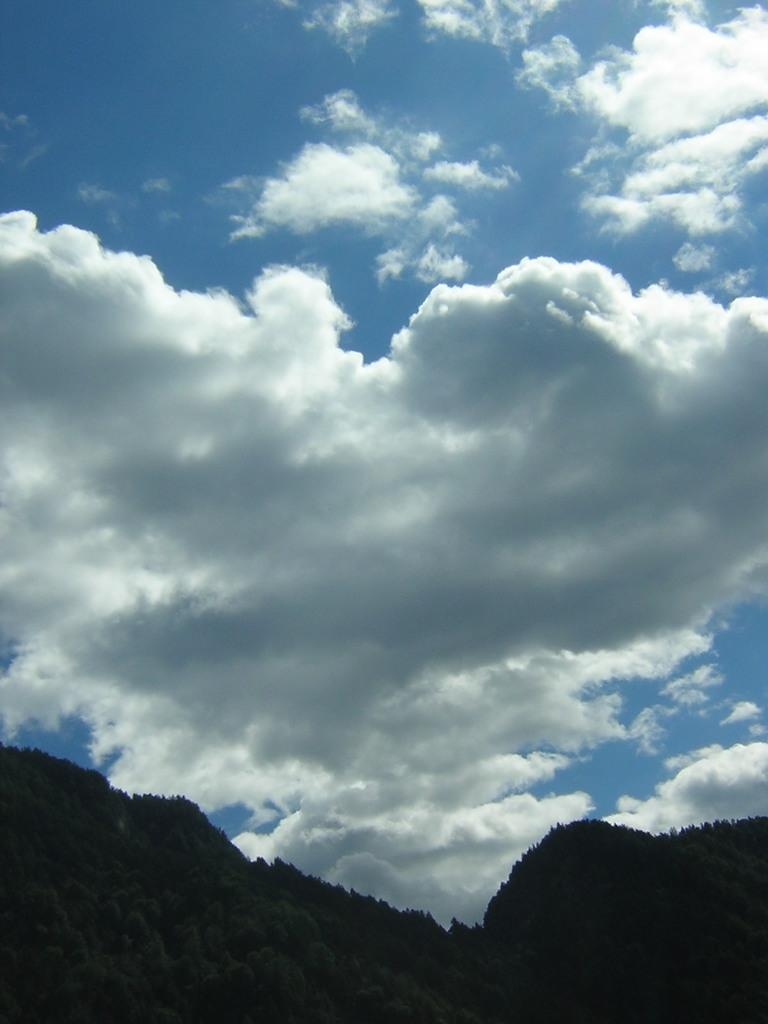What can be seen in the background of the image? The sky is visible in the image. What is present in the sky? There are clouds in the sky. What type of landscape feature can be seen in the image? There are hills in the image. What type of team is shown participating in the feast in the image? There is no team or feast present in the image; it only features the sky, clouds, and hills. 